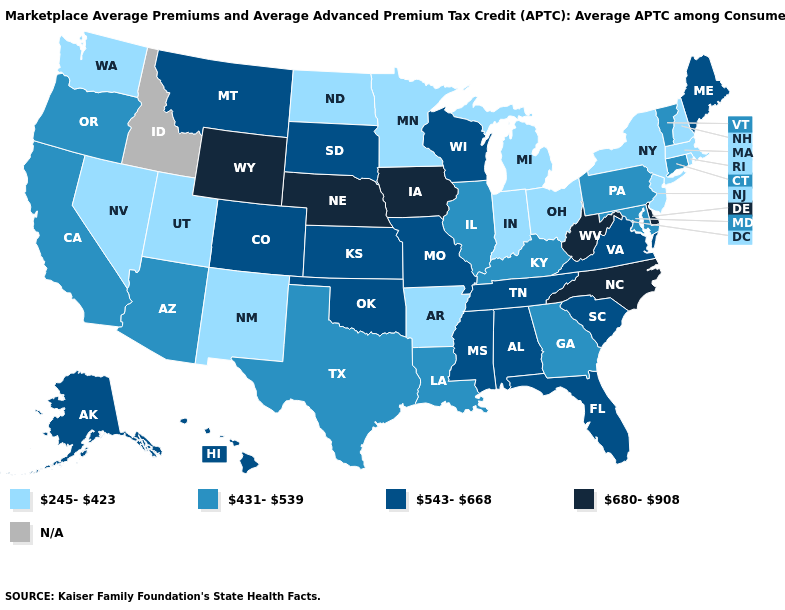How many symbols are there in the legend?
Quick response, please. 5. What is the value of New Hampshire?
Be succinct. 245-423. Name the states that have a value in the range N/A?
Concise answer only. Idaho. Does the first symbol in the legend represent the smallest category?
Short answer required. Yes. What is the value of Indiana?
Be succinct. 245-423. Name the states that have a value in the range N/A?
Be succinct. Idaho. Name the states that have a value in the range 543-668?
Be succinct. Alabama, Alaska, Colorado, Florida, Hawaii, Kansas, Maine, Mississippi, Missouri, Montana, Oklahoma, South Carolina, South Dakota, Tennessee, Virginia, Wisconsin. What is the value of New Hampshire?
Concise answer only. 245-423. Among the states that border North Dakota , does South Dakota have the highest value?
Answer briefly. Yes. Name the states that have a value in the range 543-668?
Be succinct. Alabama, Alaska, Colorado, Florida, Hawaii, Kansas, Maine, Mississippi, Missouri, Montana, Oklahoma, South Carolina, South Dakota, Tennessee, Virginia, Wisconsin. Does Maine have the highest value in the Northeast?
Give a very brief answer. Yes. What is the value of Missouri?
Quick response, please. 543-668. Does Ohio have the lowest value in the MidWest?
Be succinct. Yes. What is the value of Florida?
Give a very brief answer. 543-668. How many symbols are there in the legend?
Be succinct. 5. 